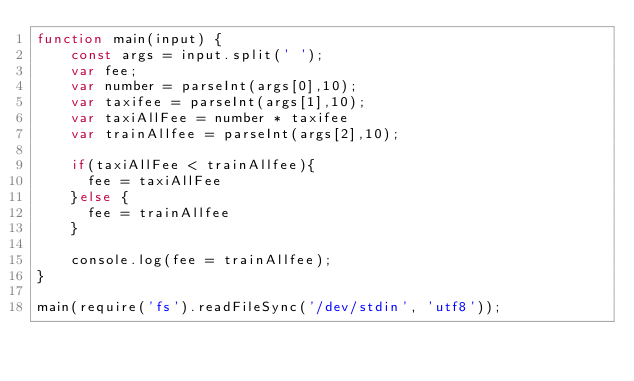Convert code to text. <code><loc_0><loc_0><loc_500><loc_500><_JavaScript_>function main(input) {
    const args = input.split(' ');
    var fee;
	var number = parseInt(args[0],10);
    var taxifee = parseInt(args[1],10);
   	var taxiAllFee = number * taxifee
    var trainAllfee = parseInt(args[2],10);
    
    if(taxiAllFee < trainAllfee){
      fee = taxiAllFee
    }else {
      fee = trainAllfee
    }
    
	console.log(fee = trainAllfee);
}

main(require('fs').readFileSync('/dev/stdin', 'utf8'));
</code> 